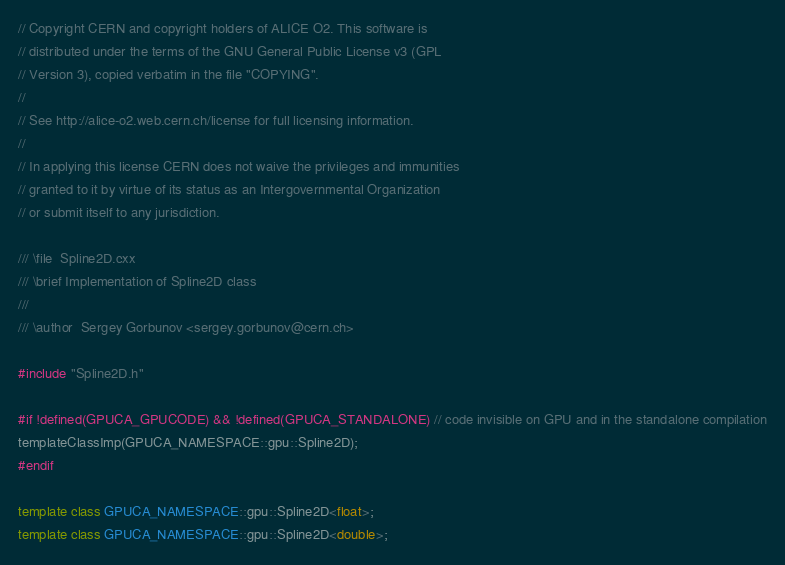<code> <loc_0><loc_0><loc_500><loc_500><_C++_>// Copyright CERN and copyright holders of ALICE O2. This software is
// distributed under the terms of the GNU General Public License v3 (GPL
// Version 3), copied verbatim in the file "COPYING".
//
// See http://alice-o2.web.cern.ch/license for full licensing information.
//
// In applying this license CERN does not waive the privileges and immunities
// granted to it by virtue of its status as an Intergovernmental Organization
// or submit itself to any jurisdiction.

/// \file  Spline2D.cxx
/// \brief Implementation of Spline2D class
///
/// \author  Sergey Gorbunov <sergey.gorbunov@cern.ch>

#include "Spline2D.h"

#if !defined(GPUCA_GPUCODE) && !defined(GPUCA_STANDALONE) // code invisible on GPU and in the standalone compilation
templateClassImp(GPUCA_NAMESPACE::gpu::Spline2D);
#endif

template class GPUCA_NAMESPACE::gpu::Spline2D<float>;
template class GPUCA_NAMESPACE::gpu::Spline2D<double>;
</code> 